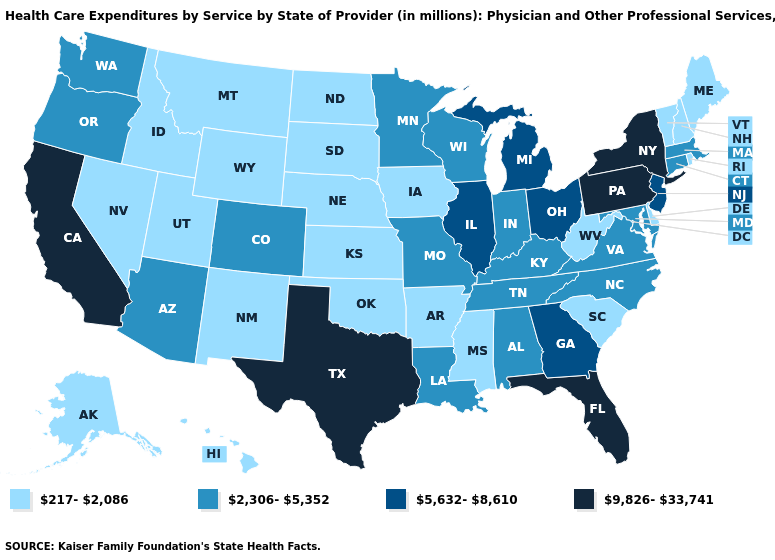Is the legend a continuous bar?
Answer briefly. No. Among the states that border Iowa , does South Dakota have the lowest value?
Answer briefly. Yes. Name the states that have a value in the range 217-2,086?
Give a very brief answer. Alaska, Arkansas, Delaware, Hawaii, Idaho, Iowa, Kansas, Maine, Mississippi, Montana, Nebraska, Nevada, New Hampshire, New Mexico, North Dakota, Oklahoma, Rhode Island, South Carolina, South Dakota, Utah, Vermont, West Virginia, Wyoming. Which states have the highest value in the USA?
Short answer required. California, Florida, New York, Pennsylvania, Texas. What is the highest value in the USA?
Short answer required. 9,826-33,741. What is the lowest value in the South?
Give a very brief answer. 217-2,086. What is the highest value in states that border Georgia?
Write a very short answer. 9,826-33,741. Name the states that have a value in the range 2,306-5,352?
Give a very brief answer. Alabama, Arizona, Colorado, Connecticut, Indiana, Kentucky, Louisiana, Maryland, Massachusetts, Minnesota, Missouri, North Carolina, Oregon, Tennessee, Virginia, Washington, Wisconsin. How many symbols are there in the legend?
Be succinct. 4. Does New York have the highest value in the USA?
Concise answer only. Yes. Among the states that border Connecticut , which have the lowest value?
Keep it brief. Rhode Island. What is the value of Kansas?
Be succinct. 217-2,086. Which states have the highest value in the USA?
Concise answer only. California, Florida, New York, Pennsylvania, Texas. What is the value of Montana?
Short answer required. 217-2,086. 